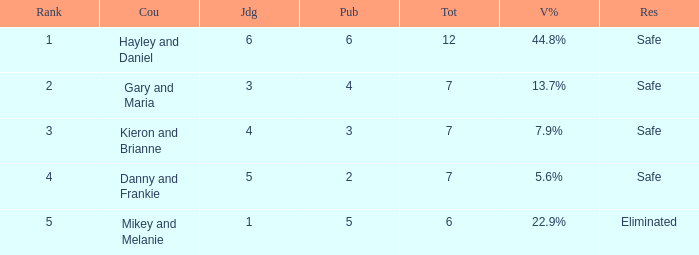What is the number of public that was there when the vote percentage was 22.9%? 1.0. 